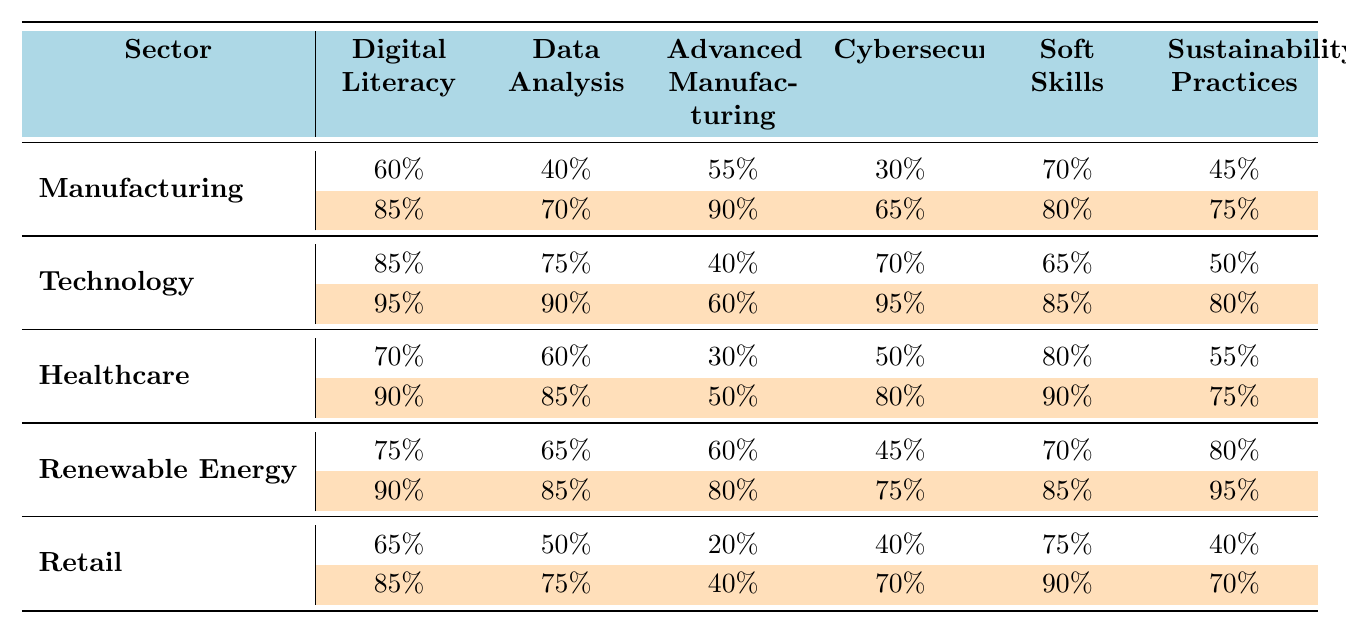What is the current percentage of Digital Literacy skills in the Healthcare sector? The table indicates that the current percentage of Digital Literacy skills in Healthcare is listed directly under the Healthcare row, which shows a value of 70%.
Answer: 70% What is the projected percentage of Data Analysis skills in the Renewable Energy sector? The projected percentage of Data Analysis skills in the Renewable Energy sector is found in the same row under the "Data Analysis" column, where it lists a projected value of 85%.
Answer: 85% Which sector has the lowest current percentage in Advanced Manufacturing skills? By examining the current percentages in the Advanced Manufacturing skill column, Retail shows the lowest value at 20%.
Answer: Retail Is the current percentage of Cybersecurity skills higher in Technology than in Healthcare? The current percentage of Cybersecurity skills for Technology is 70% and for Healthcare is 50%. Since 70% is greater than 50%, the statement is true.
Answer: Yes What is the difference between the current and projected percentage of Soft Skills in the Manufacturing sector? The current percentage of Soft Skills in Manufacturing is 70%, and the projected percentage is 80%. The difference is calculated as 80% - 70% = 10%.
Answer: 10% What sector shows the greatest increase in Digital Literacy skills from current to projected levels? Analyzing the increases, Manufacturing increases from 60% to 85%, which is a 25% increase. In Technology, it rises from 85% to 95% (10% increase), Healthcare from 70% to 90% (20% increase), Renewable Energy from 75% to 90% (15% increase), and Retail from 65% to 85% (20% increase). Manufacturing has the greatest increase.
Answer: Manufacturing What is the average current percentage of Sustainability Practices across all sectors? The current percentages for Sustainability Practices are 45%, 50%, 55%, 80%, and 40%. Adding these values gives 270%. Dividing by 5 (the number of sectors) gives an average of 54%.
Answer: 54% In which sector is the projected percentage of Advanced Manufacturing skills the highest? Looking at the projected percentages for Advanced Manufacturing, it is 90% in Manufacturing, 60% in Technology, 50% in Healthcare, 80% in Renewable Energy, and 40% in Retail. The highest is 90% in Manufacturing.
Answer: Manufacturing Are Soft Skills projected to be higher in Retail or Renewable Energy? The projected value for Soft Skills in Retail is 90%, while in Renewable Energy it is 85%. Since 90% is greater than 85%, Soft Skills are projected to be higher in Retail.
Answer: Retail What is the total current percentage of Cybersecurity skills across all sectors? Adding the current percentages for Cybersecurity: 30% (Manufacturing) + 70% (Technology) + 50% (Healthcare) + 45% (Renewable Energy) + 40% (Retail) equals 235%.
Answer: 235% 